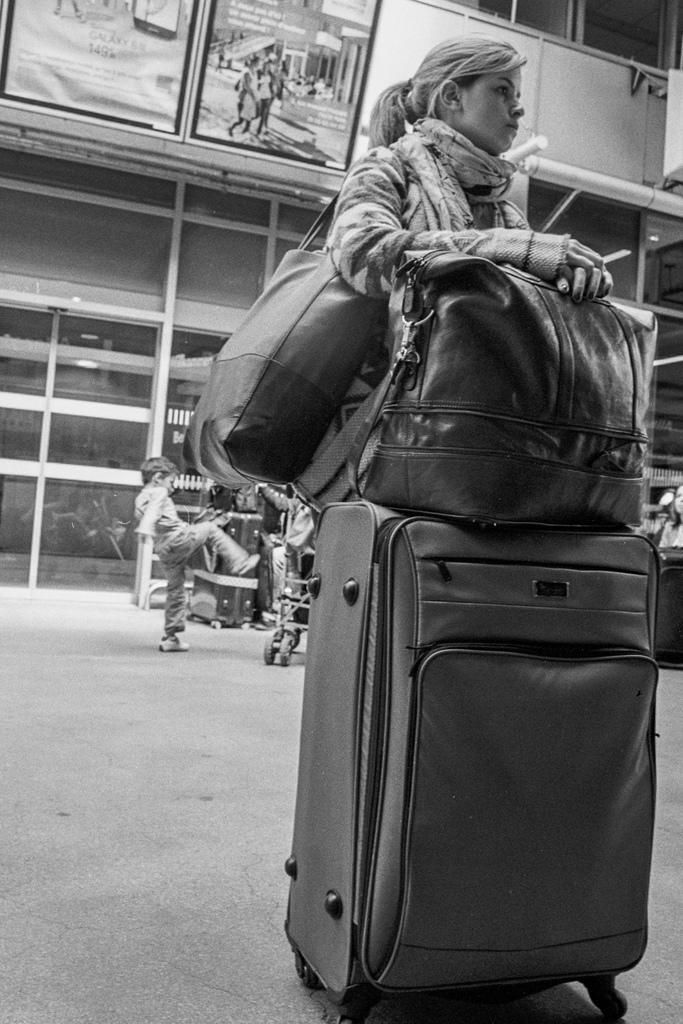Who is the main subject in the image? There is a woman in the image. What is the woman carrying in the image? The woman is carrying a bag. What else can be seen near the woman in the image? There are luggage in front of the woman. Can you describe the background of the image? There is a child in the background of the image. What type of thunder can be heard in the image? There is no sound present in the image, so it is not possible to determine if thunder can be heard. 